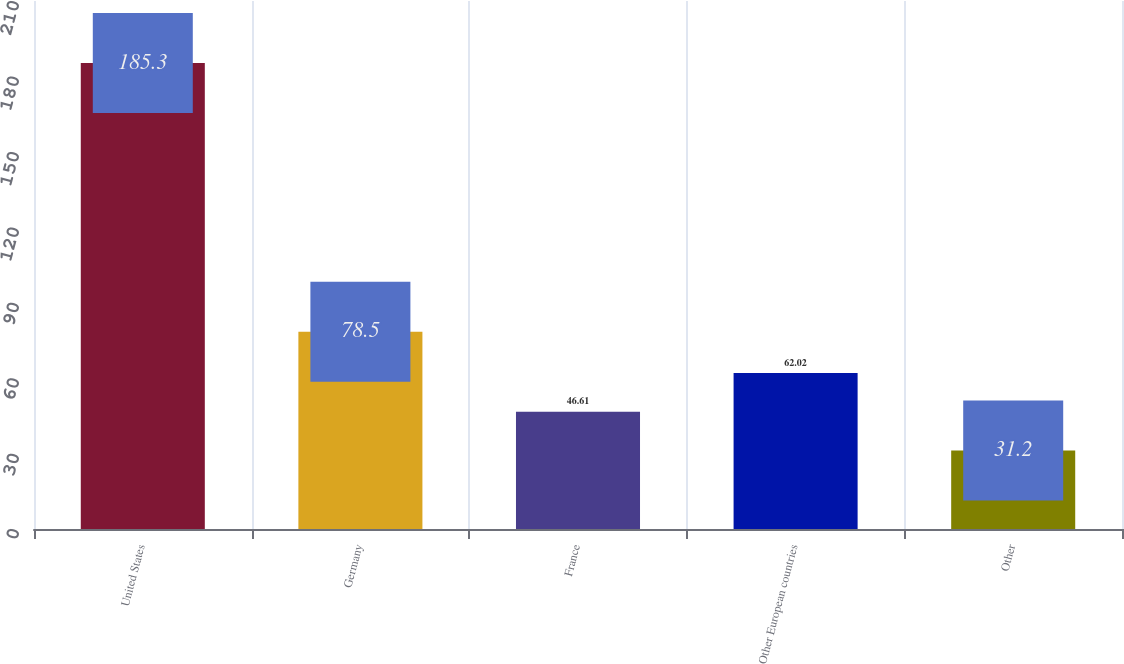Convert chart to OTSL. <chart><loc_0><loc_0><loc_500><loc_500><bar_chart><fcel>United States<fcel>Germany<fcel>France<fcel>Other European countries<fcel>Other<nl><fcel>185.3<fcel>78.5<fcel>46.61<fcel>62.02<fcel>31.2<nl></chart> 